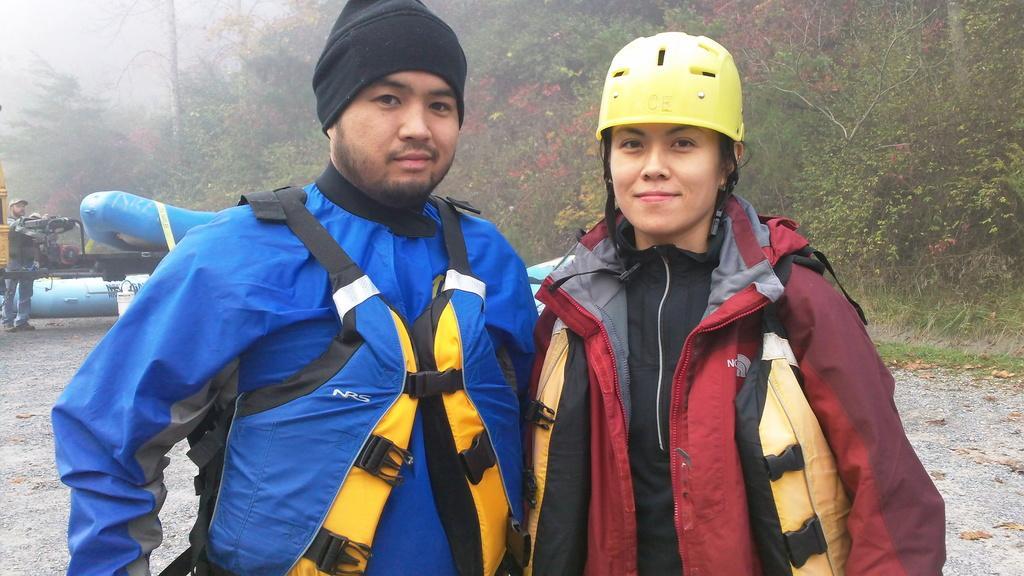How would you summarize this image in a sentence or two? There is a man and a woman wearing jackets. Man is wearing a cap and woman is wearing a helmet. In the back there are trees. Also there is a machine. 